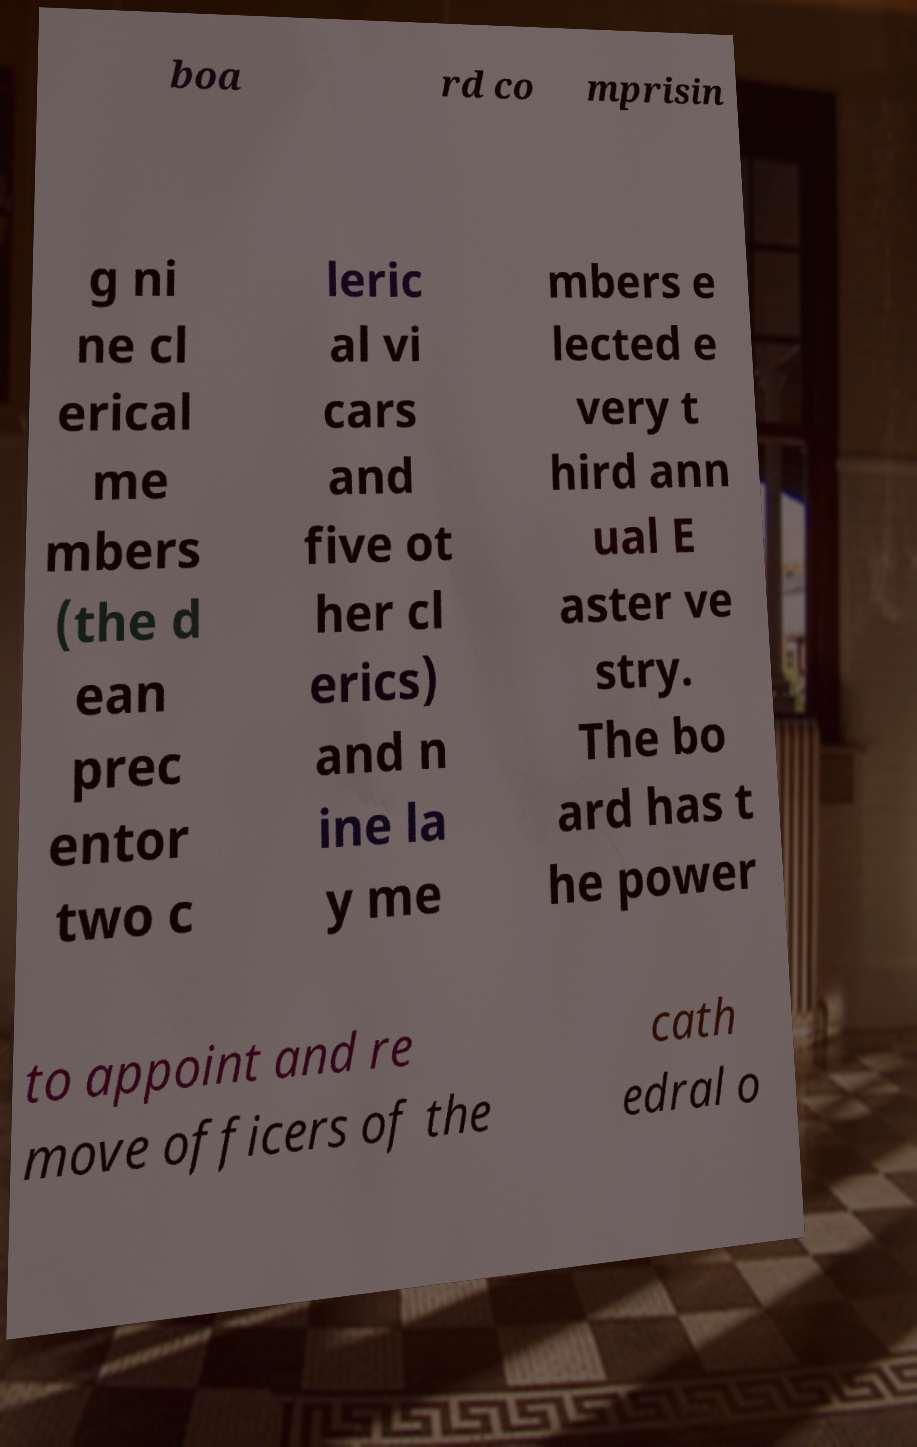There's text embedded in this image that I need extracted. Can you transcribe it verbatim? boa rd co mprisin g ni ne cl erical me mbers (the d ean prec entor two c leric al vi cars and five ot her cl erics) and n ine la y me mbers e lected e very t hird ann ual E aster ve stry. The bo ard has t he power to appoint and re move officers of the cath edral o 